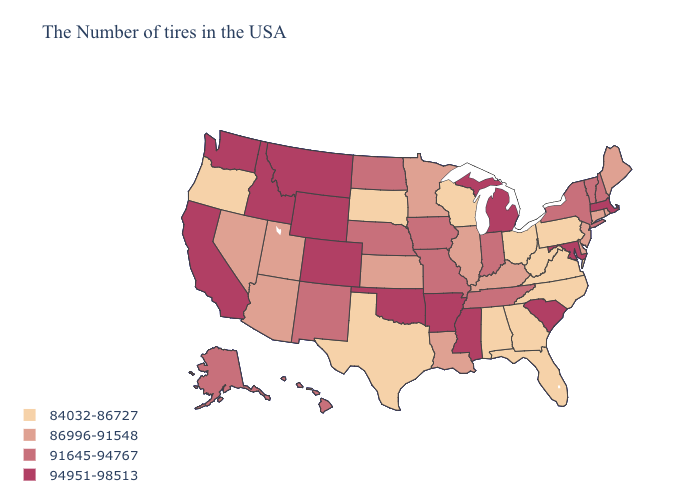Does the map have missing data?
Give a very brief answer. No. What is the value of South Dakota?
Quick response, please. 84032-86727. Name the states that have a value in the range 94951-98513?
Concise answer only. Massachusetts, Maryland, South Carolina, Michigan, Mississippi, Arkansas, Oklahoma, Wyoming, Colorado, Montana, Idaho, California, Washington. What is the lowest value in the West?
Give a very brief answer. 84032-86727. What is the highest value in states that border Massachusetts?
Write a very short answer. 91645-94767. Name the states that have a value in the range 91645-94767?
Concise answer only. New Hampshire, Vermont, New York, Indiana, Tennessee, Missouri, Iowa, Nebraska, North Dakota, New Mexico, Alaska, Hawaii. How many symbols are there in the legend?
Write a very short answer. 4. Among the states that border Arkansas , does Louisiana have the highest value?
Concise answer only. No. Does Texas have the lowest value in the USA?
Be succinct. Yes. Among the states that border Illinois , which have the lowest value?
Write a very short answer. Wisconsin. Name the states that have a value in the range 84032-86727?
Keep it brief. Pennsylvania, Virginia, North Carolina, West Virginia, Ohio, Florida, Georgia, Alabama, Wisconsin, Texas, South Dakota, Oregon. What is the highest value in states that border North Dakota?
Be succinct. 94951-98513. Among the states that border Louisiana , which have the highest value?
Concise answer only. Mississippi, Arkansas. 